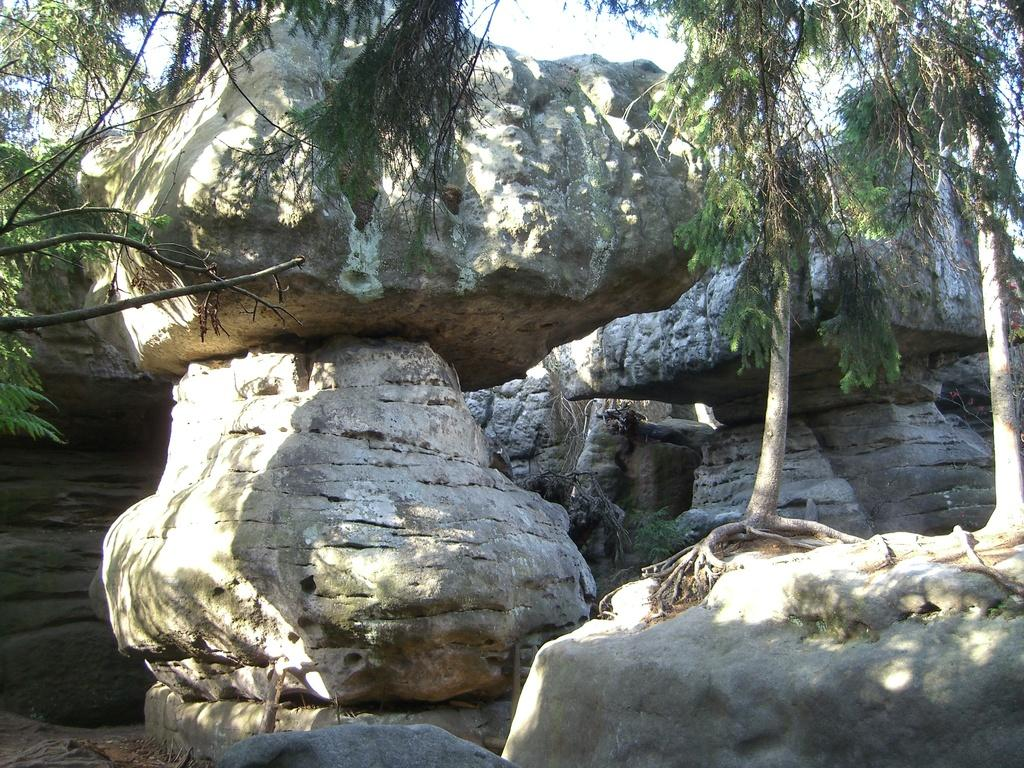What type of natural elements can be seen in the image? There are rocks and trees in the image. Can you describe the rocks in the image? The rocks in the image are likely solid, natural formations. What type of vegetation is present in the image? Trees are the type of vegetation present in the image. What type of vehicle can be seen driving through the image? There is no vehicle present in the image; it features rocks and trees. What type of bird is depicted in the image? There is no bird present in the image; it features rocks and trees. 